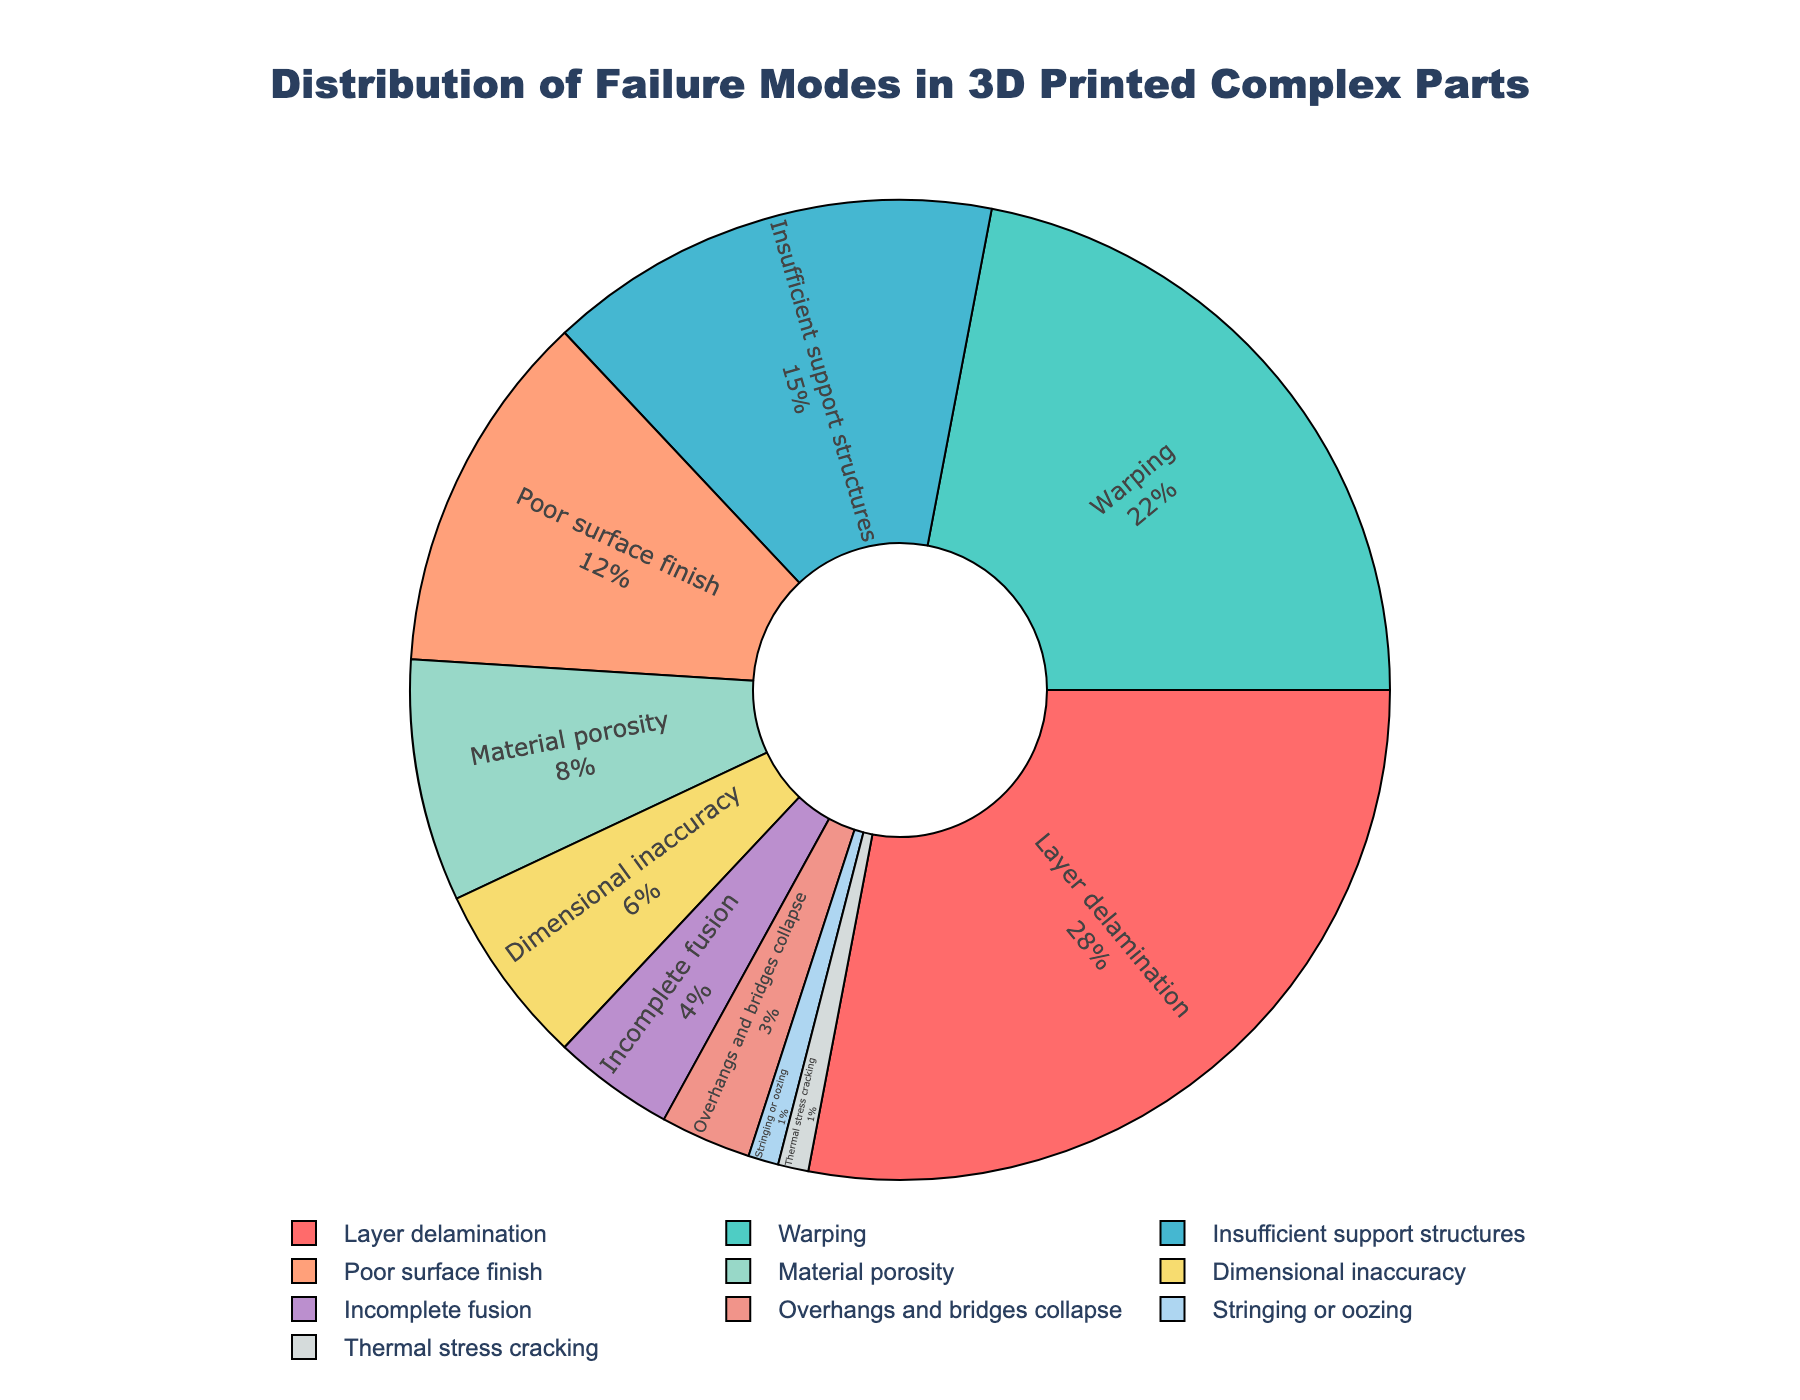What is the most common failure mode in 3D printed complex parts? By looking at the pie chart, the largest slice represents the most common failure mode. The failure mode labeled "Layer delamination" has the largest slice with 28%.
Answer: Layer delamination Which failure mode accounts for a smaller percentage: Warping or Insufficient support structures? Compare the slices labeled "Warping" and "Insufficient support structures" in the chart. "Warping" accounts for 22% while "Insufficient support structures" accounts for 15%. Therefore, "Insufficient support structures" accounts for a smaller percentage.
Answer: Insufficient support structures What is the combined percentage of the three least common failure modes? The three least common failure modes are "Stringing or oozing" (1%), "Thermal stress cracking" (1%), and "Overhangs and bridges collapse" (3%). Adding these percentages gives 1% + 1% + 3% = 5%.
Answer: 5% Which failure modes together make up more than 50% of the failures? Identify the large slices in the chart so their percentages add to more than 50%. The largest slices are for "Layer delamination" (28%), "Warping" (22%), and "Insufficient support structures" (15%). Adding these gives 28% + 22% + 15% = 65%, which is more than 50%.
Answer: Layer delamination, Warping, Insufficient support structures How much larger is the percentage for Layer delamination compared to Poor surface finish? Subtract the percentage of "Poor surface finish" (12%) from the percentage of "Layer delamination" (28%). 28% - 12% = 16%.
Answer: 16% Among the failure modes, which one is represented by the red slice, and what percentage does it represent? The visual attribute (color) of the slice helps identify the failure mode. The red slice represents "Layer delamination" which accounts for 28%.
Answer: Layer delamination, 28% What is the average percentage for Material porosity, Dimensional inaccuracy, and Incomplete fusion? Add the percentages of "Material porosity" (8%), "Dimensional inaccuracy" (6%), and "Incomplete fusion" (4%) and then divide by 3. (8% + 6% + 4%) / 3 = 18% / 3 = 6%.
Answer: 6% Which failure mode is least common, and what color is its slice? The smallest slice on the chart identifies the least common failure mode which is "Thermal stress cracking" and "Stringing or oozing," both 1%. The slice color for "Thermal stress cracking" and "Stringing or oozing" needs to be inferred from the specific color scheme provided in the problem but is typically light shades used for very small values.
Answer: Stringing or oozing, Thermal stress cracking, light color Which failure mode has a percentage closest to Material porosity, and what is its value? Find "Material porosity" (8%) on the chart. The failure mode closest to this value is "Dimensional inaccuracy" with 6%.
Answer: Dimensional inaccuracy, 6% 